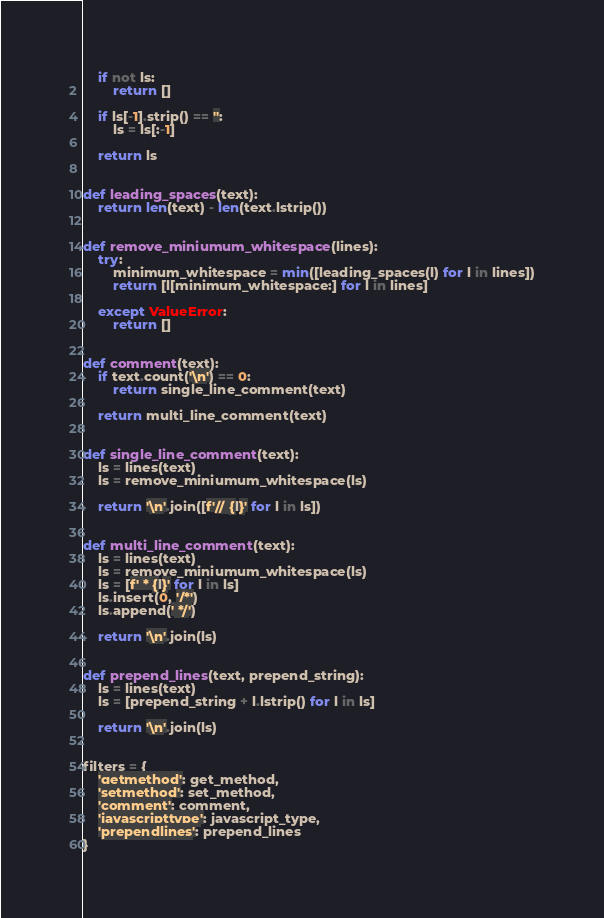<code> <loc_0><loc_0><loc_500><loc_500><_Python_>
    if not ls:
        return []

    if ls[-1].strip() == '':
        ls = ls[:-1]

    return ls


def leading_spaces(text):
    return len(text) - len(text.lstrip())


def remove_miniumum_whitespace(lines):
    try:
        minimum_whitespace = min([leading_spaces(l) for l in lines])
        return [l[minimum_whitespace:] for l in lines]

    except ValueError:
        return []


def comment(text):
    if text.count('\n') == 0:
        return single_line_comment(text)

    return multi_line_comment(text)


def single_line_comment(text):
    ls = lines(text)
    ls = remove_miniumum_whitespace(ls)

    return '\n'.join([f'// {l}' for l in ls])


def multi_line_comment(text):
    ls = lines(text)
    ls = remove_miniumum_whitespace(ls)
    ls = [f' * {l}' for l in ls]
    ls.insert(0, '/*')
    ls.append(' */')

    return '\n'.join(ls)


def prepend_lines(text, prepend_string):
    ls = lines(text)
    ls = [prepend_string + l.lstrip() for l in ls]

    return '\n'.join(ls)


filters = {
    'getmethod': get_method,
    'setmethod': set_method,
    'comment': comment,
    'javascripttype': javascript_type,
    'prependlines': prepend_lines
}</code> 